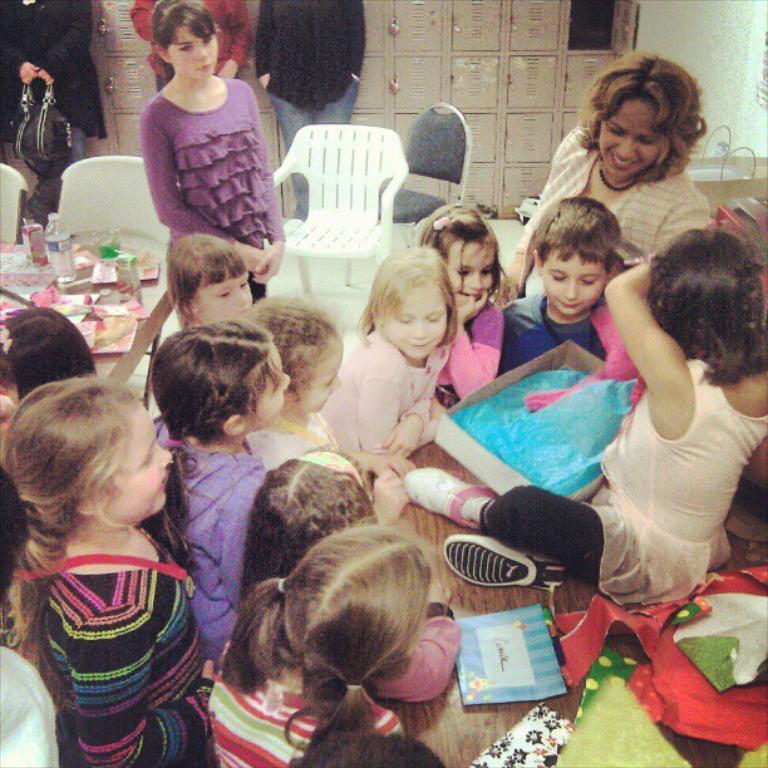In one or two sentences, can you explain what this image depicts? There are so many kids standing around the table and one kid sitting on a table holding box. Behind them there are two woman standing and staring at kids and there are few chairs and lockers in room. 